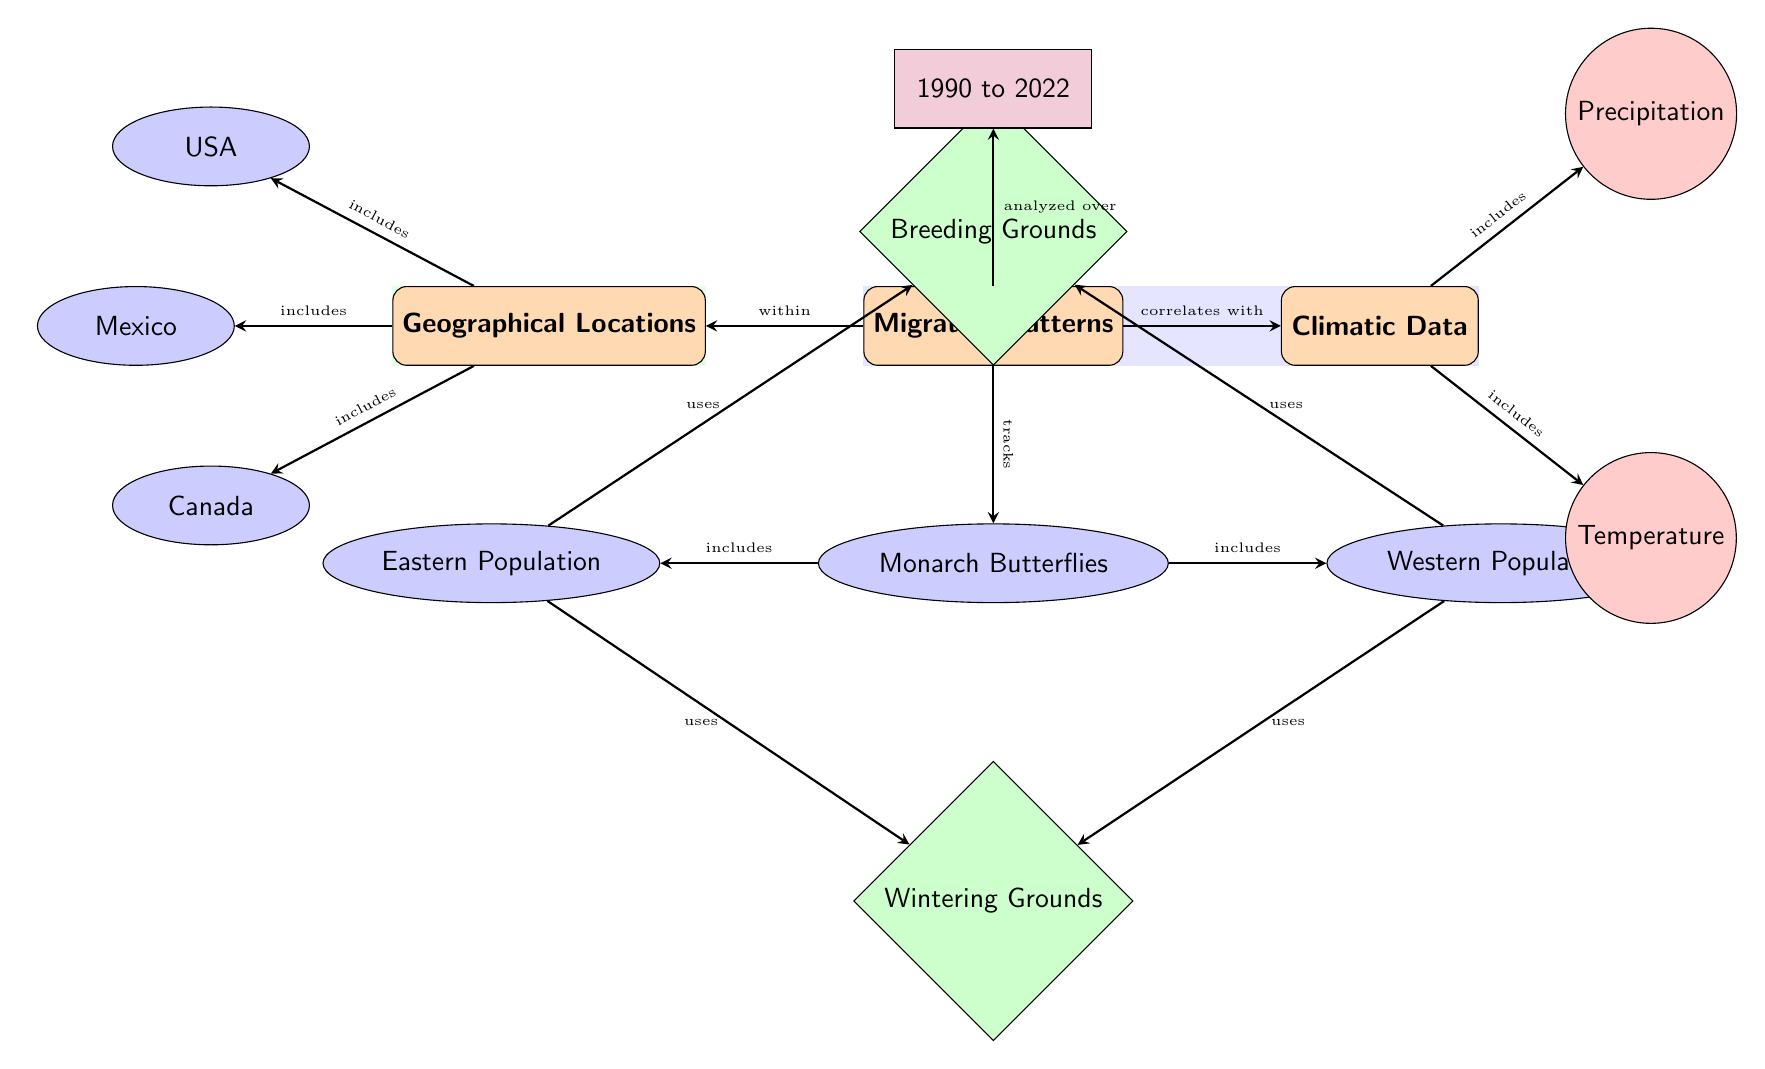What are the two populations of monarch butterflies represented in the diagram? The diagram identifies the two populations as the Eastern Population and the Western Population. These nodes are connected to the Monarch Butterflies entity, indicating their inclusion.
Answer: Eastern Population, Western Population What climatic metrics are included in the diagram? The diagram includes two climatic metrics: Temperature and Precipitation. These metrics are displayed under the Climatic Data category and are connected to it.
Answer: Temperature, Precipitation Which geographical locations are associated with the migration patterns of monarch butterflies? The diagram lists three geographical locations related to the migration: USA, Mexico, and Canada. These locations are connected under the Geographical Locations category.
Answer: USA, Mexico, Canada How does the diagram correlate migration patterns with climatic data? The migration patterns are shown to correlate with climatic data through an arrow connecting the Migration Patterns node to the Climatic Data node, indicating a relationship.
Answer: Correlates What is the timespan over which the migration patterns are analyzed? The timespan indicated in the diagram for analyzing the migration patterns is from 1990 to 2022, as represented by the Timespan node.
Answer: 1990 to 2022 What connection is made between the eastern population and wintering grounds? The diagram shows that the Eastern Population uses the Wintering Grounds, as indicated by the arrow moving from the Eastern Population to the Wintering Grounds.
Answer: Uses Which population of monarch butterflies uses both wintering and breeding grounds? Both the Eastern Population and the Western Population use the Wintering Grounds and the Breeding Grounds, as indicated by the arrows that connect these nodes reciprocally to their respective breeding and wintering grounds.
Answer: Both populations How are the geographical locations related to migration patterns specifically within the diagram? The geographical locations of the USA, Mexico, and Canada are stated to include areas relevant to the migration patterns, connected through an arrow from the Migration Patterns node to the Geographical Locations node, indicating their inclusion.
Answer: Included 